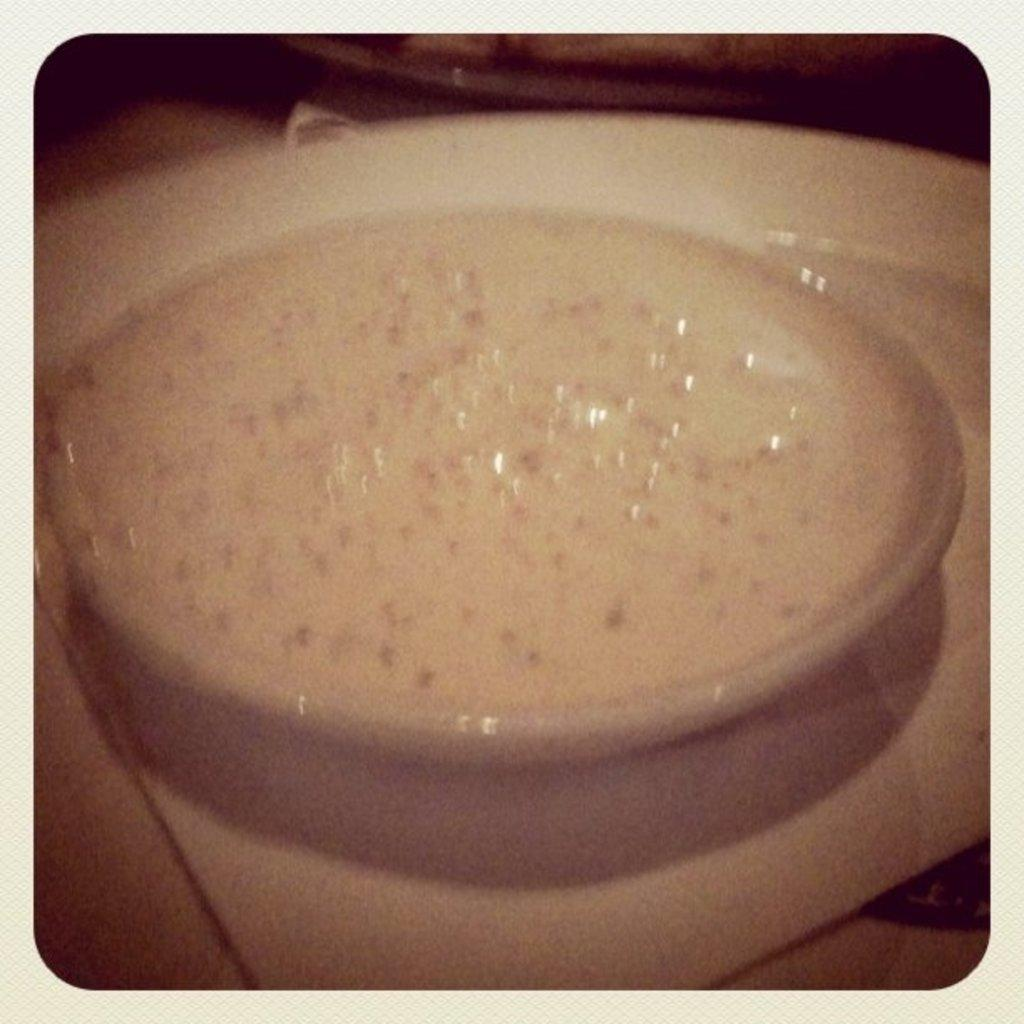What is located in the center of the image? There is a plate in the center of the image. What is on the plate? There is food on the plate. Can you describe anything visible in the background of the image? Unfortunately, the facts provided do not give any specific details about the objects in the background. How many mice are hiding under the plate in the image? There are no mice present in the image. What type of account is being discussed in the image? There is no mention of an account in the image. 